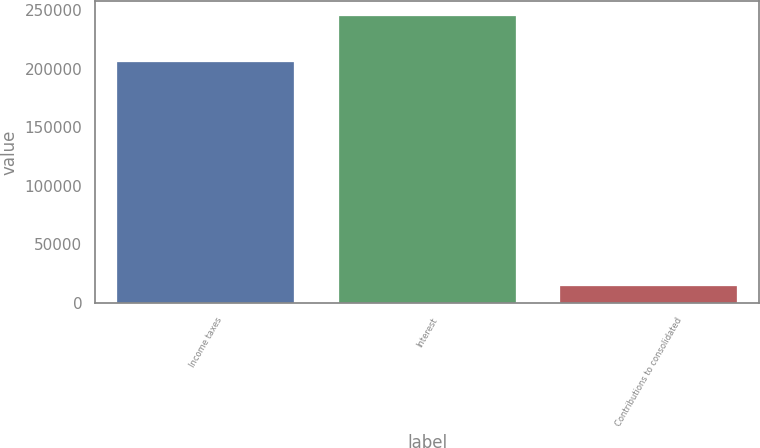Convert chart. <chart><loc_0><loc_0><loc_500><loc_500><bar_chart><fcel>Income taxes<fcel>Interest<fcel>Contributions to consolidated<nl><fcel>205955<fcel>245325<fcel>14735<nl></chart> 